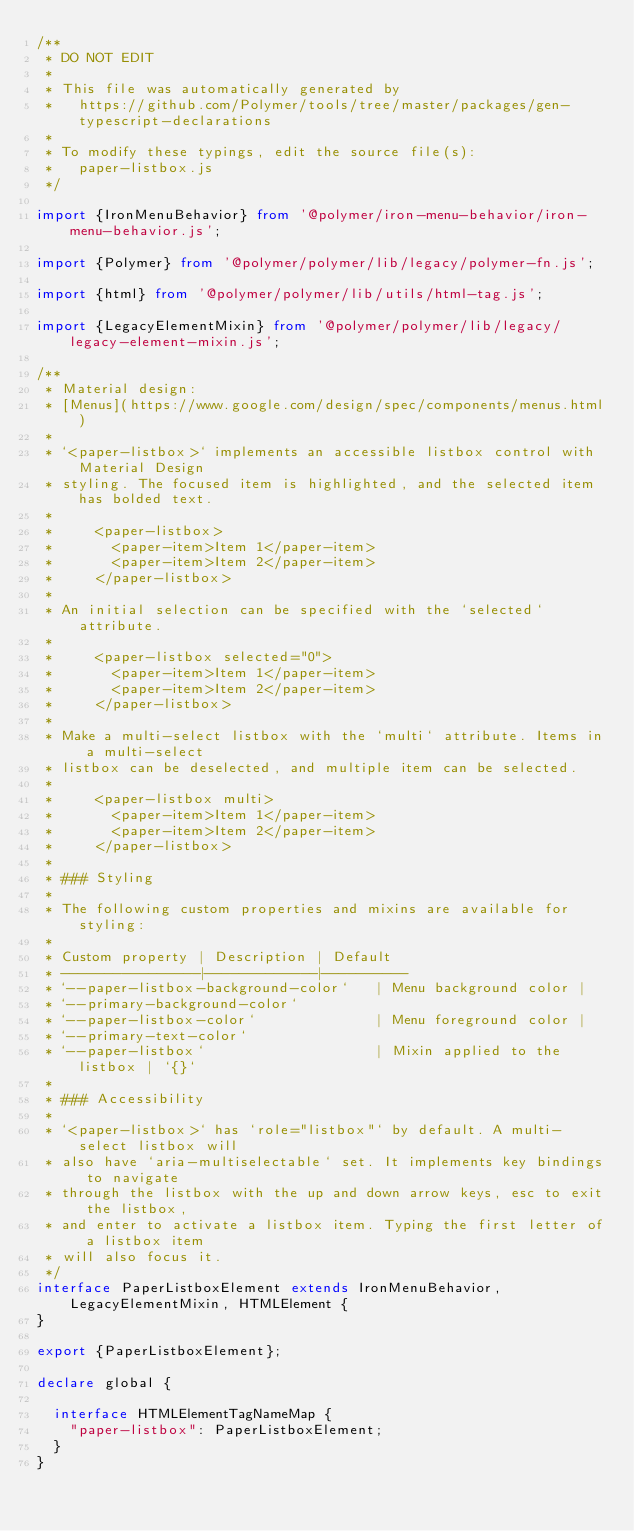<code> <loc_0><loc_0><loc_500><loc_500><_TypeScript_>/**
 * DO NOT EDIT
 *
 * This file was automatically generated by
 *   https://github.com/Polymer/tools/tree/master/packages/gen-typescript-declarations
 *
 * To modify these typings, edit the source file(s):
 *   paper-listbox.js
 */

import {IronMenuBehavior} from '@polymer/iron-menu-behavior/iron-menu-behavior.js';

import {Polymer} from '@polymer/polymer/lib/legacy/polymer-fn.js';

import {html} from '@polymer/polymer/lib/utils/html-tag.js';

import {LegacyElementMixin} from '@polymer/polymer/lib/legacy/legacy-element-mixin.js';

/**
 * Material design:
 * [Menus](https://www.google.com/design/spec/components/menus.html)
 *
 * `<paper-listbox>` implements an accessible listbox control with Material Design
 * styling. The focused item is highlighted, and the selected item has bolded text.
 *
 *     <paper-listbox>
 *       <paper-item>Item 1</paper-item>
 *       <paper-item>Item 2</paper-item>
 *     </paper-listbox>
 *
 * An initial selection can be specified with the `selected` attribute.
 *
 *     <paper-listbox selected="0">
 *       <paper-item>Item 1</paper-item>
 *       <paper-item>Item 2</paper-item>
 *     </paper-listbox>
 *
 * Make a multi-select listbox with the `multi` attribute. Items in a multi-select
 * listbox can be deselected, and multiple item can be selected.
 *
 *     <paper-listbox multi>
 *       <paper-item>Item 1</paper-item>
 *       <paper-item>Item 2</paper-item>
 *     </paper-listbox>
 *
 * ### Styling
 *
 * The following custom properties and mixins are available for styling:
 *
 * Custom property | Description | Default
 * ----------------|-------------|----------
 * `--paper-listbox-background-color`   | Menu background color |
 * `--primary-background-color`
 * `--paper-listbox-color`              | Menu foreground color |
 * `--primary-text-color`
 * `--paper-listbox`                    | Mixin applied to the listbox | `{}`
 *
 * ### Accessibility
 *
 * `<paper-listbox>` has `role="listbox"` by default. A multi-select listbox will
 * also have `aria-multiselectable` set. It implements key bindings to navigate
 * through the listbox with the up and down arrow keys, esc to exit the listbox,
 * and enter to activate a listbox item. Typing the first letter of a listbox item
 * will also focus it.
 */
interface PaperListboxElement extends IronMenuBehavior, LegacyElementMixin, HTMLElement {
}

export {PaperListboxElement};

declare global {

  interface HTMLElementTagNameMap {
    "paper-listbox": PaperListboxElement;
  }
}
</code> 